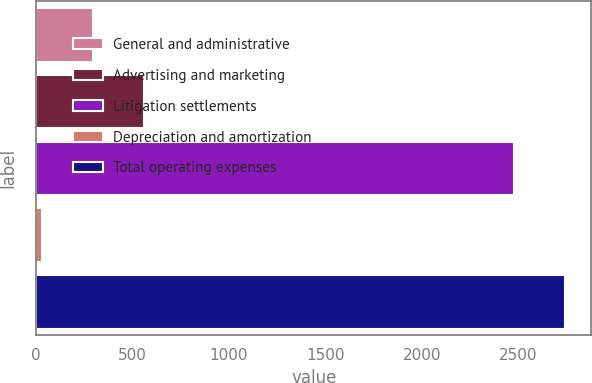Convert chart to OTSL. <chart><loc_0><loc_0><loc_500><loc_500><bar_chart><fcel>General and administrative<fcel>Advertising and marketing<fcel>Litigation settlements<fcel>Depreciation and amortization<fcel>Total operating expenses<nl><fcel>294.8<fcel>560.6<fcel>2476<fcel>29<fcel>2741.8<nl></chart> 